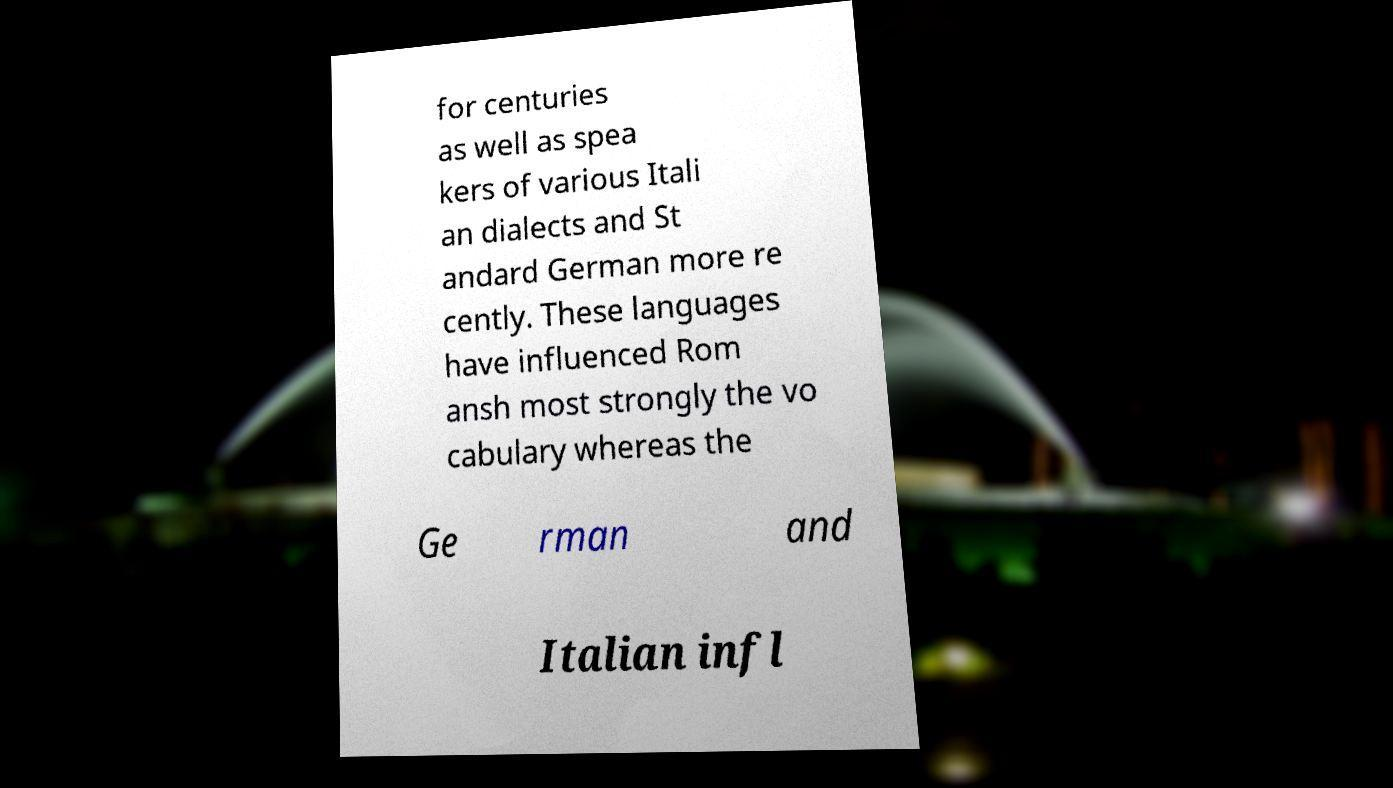What messages or text are displayed in this image? I need them in a readable, typed format. for centuries as well as spea kers of various Itali an dialects and St andard German more re cently. These languages have influenced Rom ansh most strongly the vo cabulary whereas the Ge rman and Italian infl 